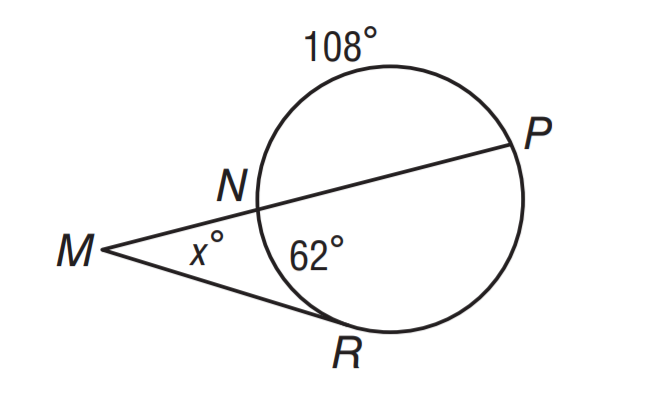How might we use this diagram to explain the properties of angles created by a tangent and a secant line coming from a common endpoint outside a circle? This diagram is perfect for illustrating the angle properties involving a tangent and a secant line. The angle formed between the tangent at N and the secant line NP is an exterior angle to the circle, and its measure is equal to the difference between the measure of the intercepted arc (RNP) and the measure of the interior angle at point N formed by the secant line intersecting the circle twice (m \widehat N R). This can lead to a broader discussion on the tangent-secant angle theorem, which is an important concept in circle geometry. 